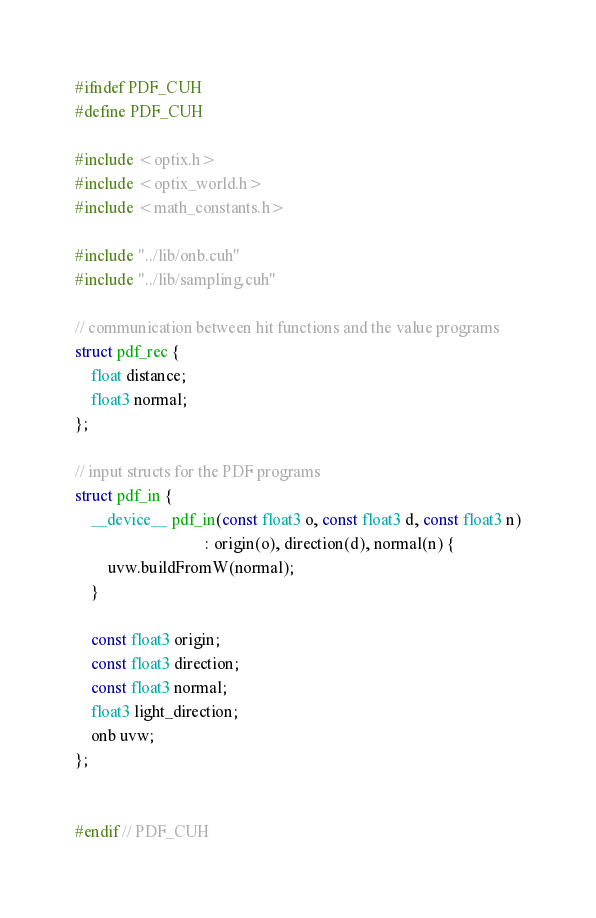<code> <loc_0><loc_0><loc_500><loc_500><_Cuda_>#ifndef PDF_CUH
#define PDF_CUH

#include <optix.h>
#include <optix_world.h>
#include <math_constants.h>

#include "../lib/onb.cuh"
#include "../lib/sampling.cuh"

// communication between hit functions and the value programs
struct pdf_rec {
    float distance;
    float3 normal;
};

// input structs for the PDF programs
struct pdf_in {
    __device__ pdf_in(const float3 o, const float3 d, const float3 n)
                                : origin(o), direction(d), normal(n) {
        uvw.buildFromW(normal);
    }

    const float3 origin;
    const float3 direction;
    const float3 normal;
    float3 light_direction;
    onb uvw;
};


#endif // PDF_CUH
</code> 